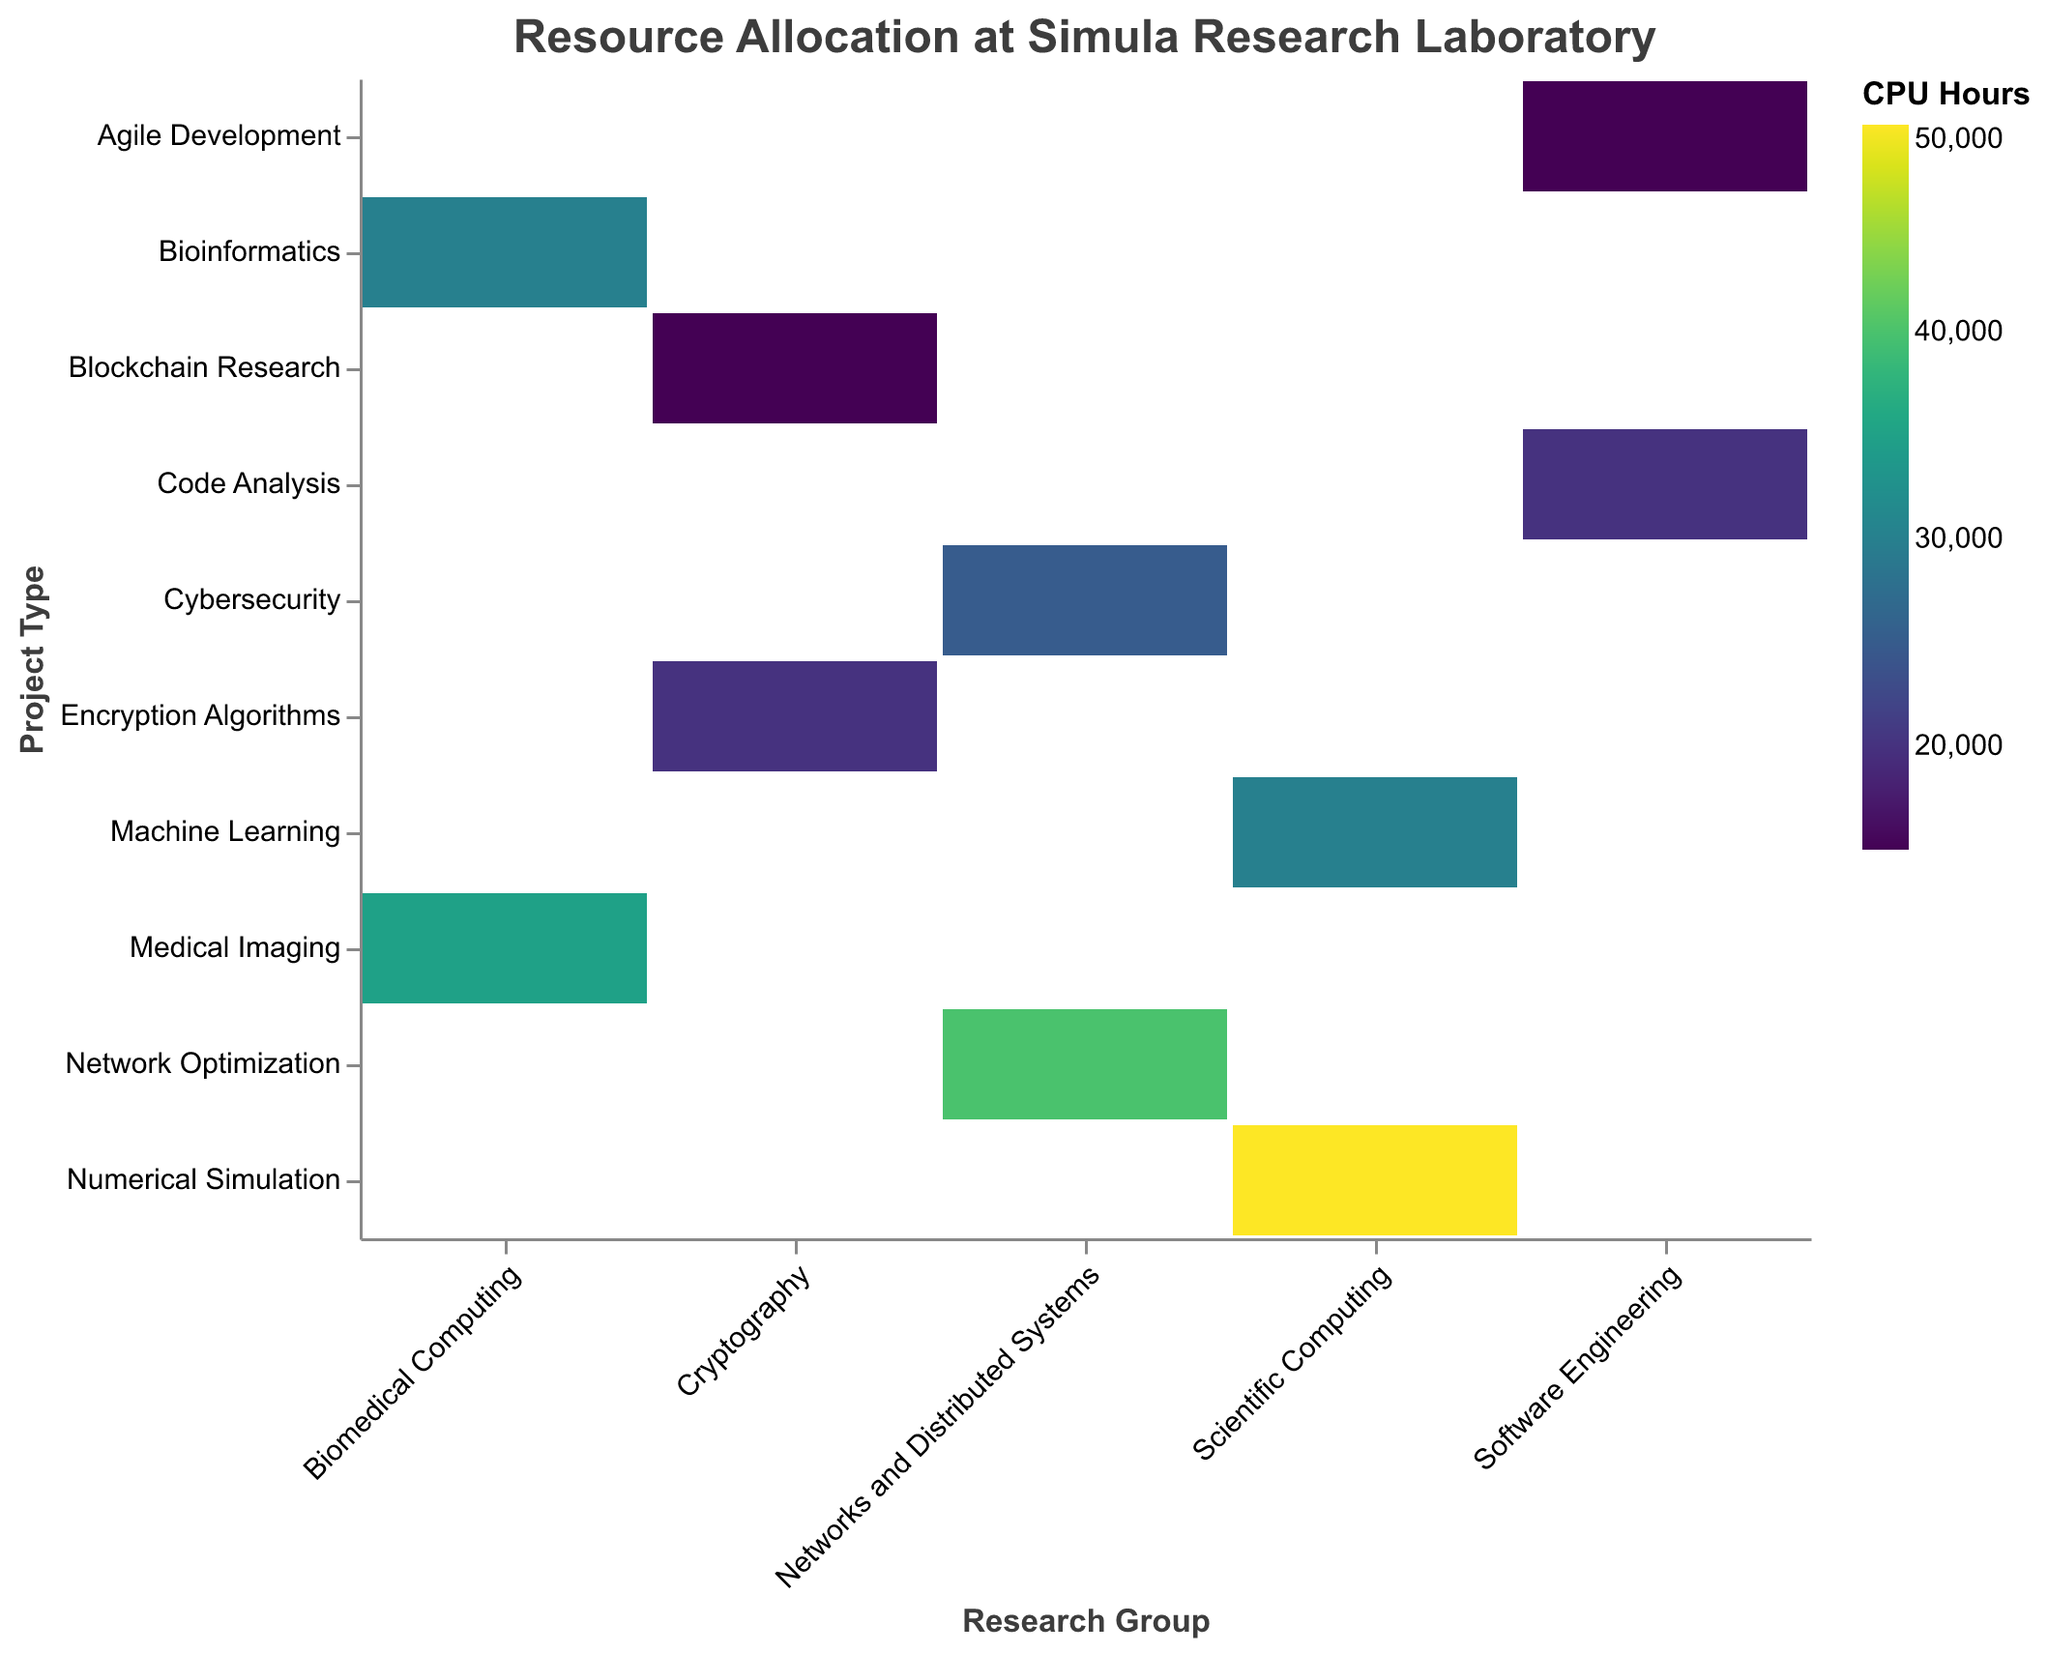What's the title of the figure? The title is displayed at the top of the figure.
Answer: Resource Allocation at Simula Research Laboratory Which project within the Scientific Computing group has the highest CPU hours allocation? By looking at the intersections of the Scientific Computing group with its respective projects, the project with the darkest color indicates the highest CPU hours. Numerical Simulation has a darker color than Machine Learning.
Answer: Numerical Simulation Which research group has the lowest total CPU hours allocation? Visually estimate the area or the color intensity of rectangles within each group. The Cryptography group has less combined area and lighter colors compared to others.
Answer: Cryptography What is the total CPU hours allocation for the Networks and Distributed Systems group? Sum the CPU hours allocated to Network Optimization and Cybersecurity projects within this group: 40000 + 25000.
Answer: 65000 Compare the CPU hours allocated to Medical Imaging with Bioinformatics within Biomedical Computing. Which has more, and by how much? Check the colors or the size of the rectangles for both projects in the Biomedical Computing group. Medical Imaging (35000) has more than Bioinformatics (30000). The difference is 35000 - 30000.
Answer: Medical Imaging by 5000 Which project has the same CPU hours allocation as Code Analysis? Identify the CPU hours for Code Analysis (20000) and look for another project with the same intensity or numerical value. Encryption Algorithms also has 20000 CPU hours.
Answer: Encryption Algorithms What is the average CPU hours allocation for projects within the Cryptography group? Add the CPU hours for Encryption Algorithms (20000) and Blockchain Research (15000) and divide by 2. (20000 + 15000) / 2 = 17500.
Answer: 17500 How does the allocation for Machine Learning in Scientific Computing compare to Cybersecurity in Networks and Distributed Systems? Look at the respective rectangles for Machine Learning and Cybersecurity. Machine Learning has a larger area and darker color. 30000 > 25000.
Answer: Machine Learning has more Which research group has the most evenly distributed allocation among its projects? Compare the color intensity difference within each research group. Software Engineering’s projects (Code Analysis and Agile Development) have similar colors and areas.
Answer: Software Engineering 